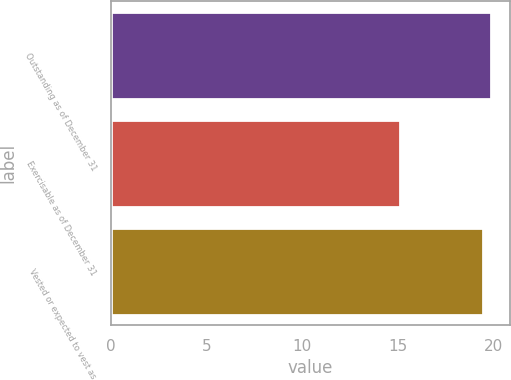Convert chart. <chart><loc_0><loc_0><loc_500><loc_500><bar_chart><fcel>Outstanding as of December 31<fcel>Exercisable as of December 31<fcel>Vested or expected to vest as<nl><fcel>19.91<fcel>15.14<fcel>19.46<nl></chart> 